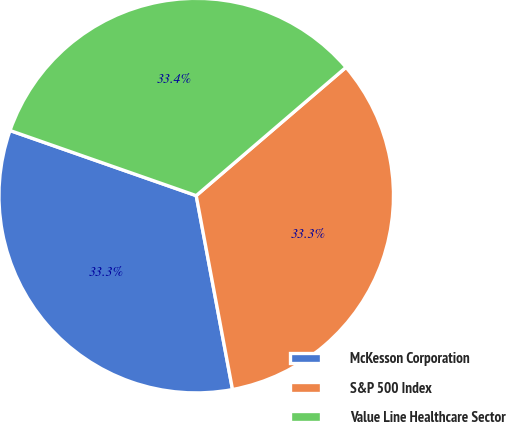Convert chart. <chart><loc_0><loc_0><loc_500><loc_500><pie_chart><fcel>McKesson Corporation<fcel>S&P 500 Index<fcel>Value Line Healthcare Sector<nl><fcel>33.3%<fcel>33.33%<fcel>33.37%<nl></chart> 